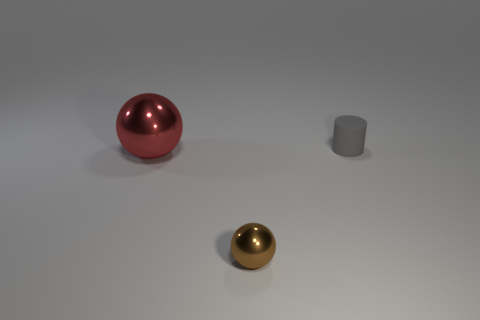Add 1 large yellow metallic cylinders. How many objects exist? 4 Subtract all cylinders. How many objects are left? 2 Add 3 tiny brown balls. How many tiny brown balls exist? 4 Subtract 0 green spheres. How many objects are left? 3 Subtract all small brown rubber cubes. Subtract all gray objects. How many objects are left? 2 Add 2 rubber objects. How many rubber objects are left? 3 